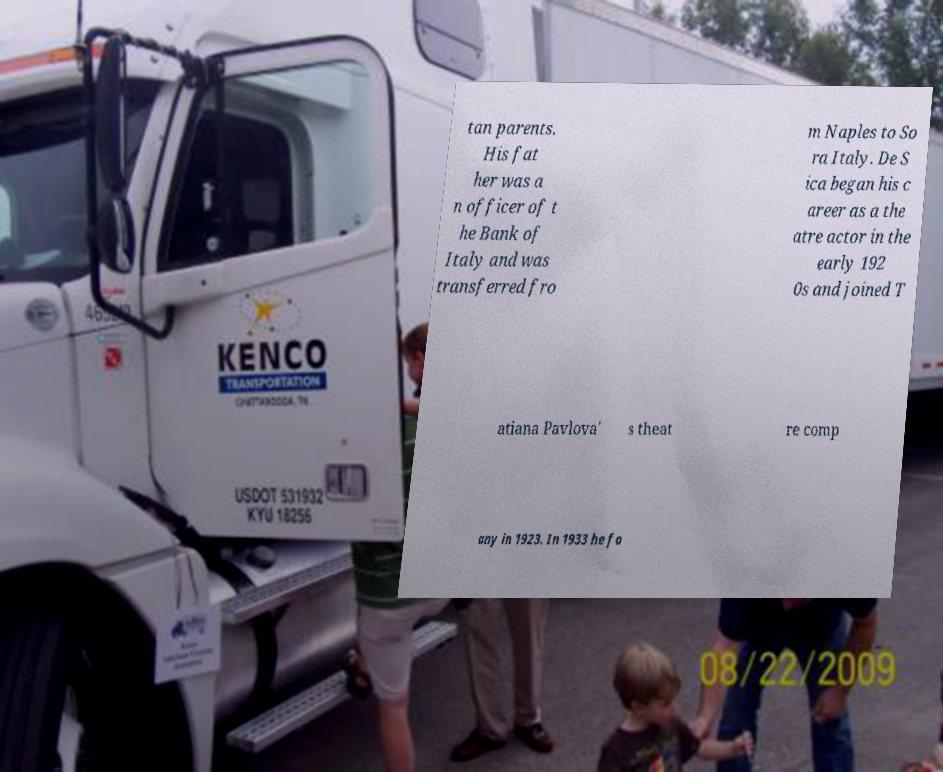Could you assist in decoding the text presented in this image and type it out clearly? tan parents. His fat her was a n officer of t he Bank of Italy and was transferred fro m Naples to So ra Italy. De S ica began his c areer as a the atre actor in the early 192 0s and joined T atiana Pavlova' s theat re comp any in 1923. In 1933 he fo 